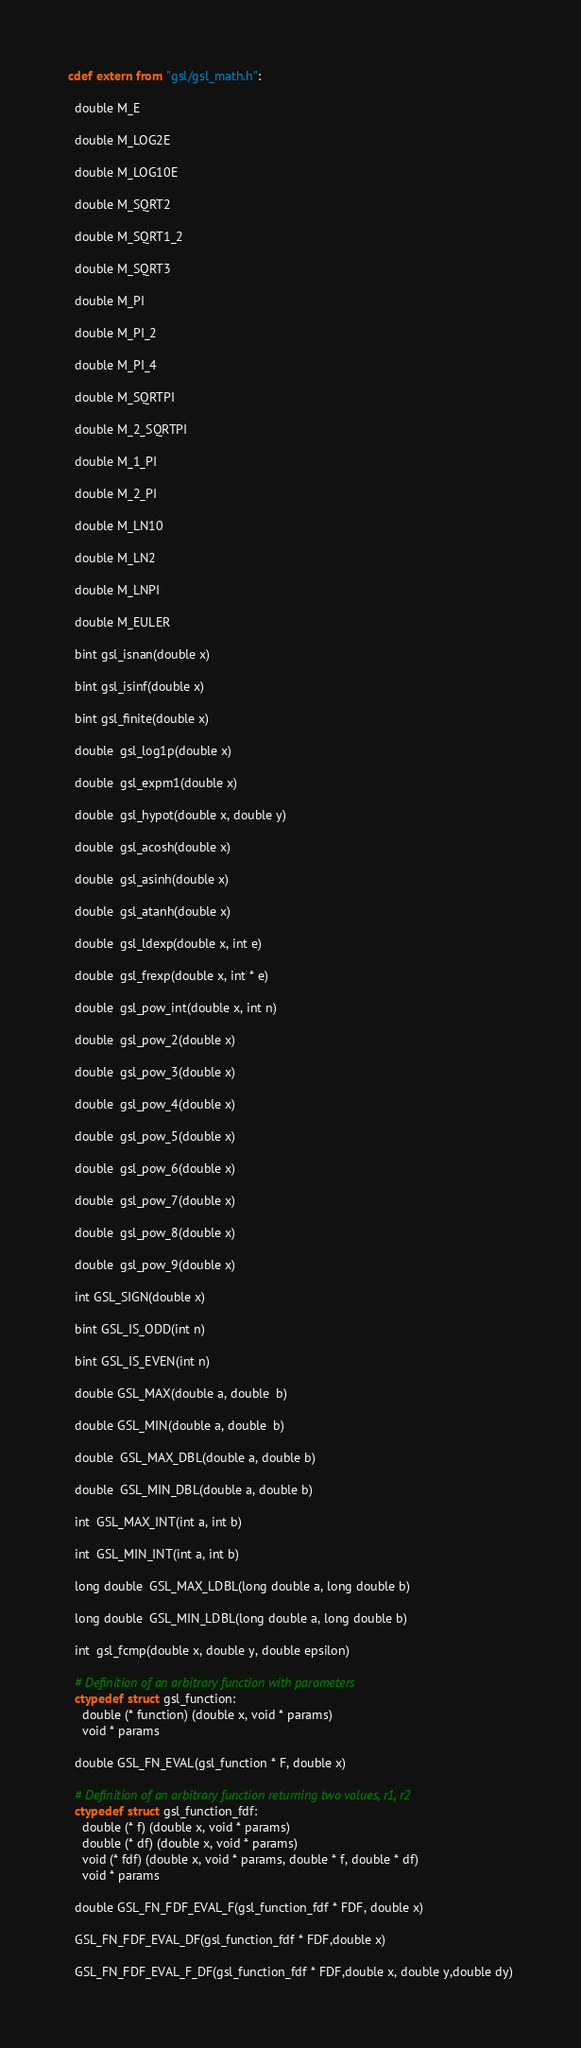Convert code to text. <code><loc_0><loc_0><loc_500><loc_500><_Cython_>cdef extern from "gsl/gsl_math.h":

  double M_E

  double M_LOG2E

  double M_LOG10E

  double M_SQRT2

  double M_SQRT1_2

  double M_SQRT3

  double M_PI

  double M_PI_2

  double M_PI_4

  double M_SQRTPI

  double M_2_SQRTPI

  double M_1_PI

  double M_2_PI

  double M_LN10

  double M_LN2

  double M_LNPI

  double M_EULER

  bint gsl_isnan(double x)

  bint gsl_isinf(double x)

  bint gsl_finite(double x)

  double  gsl_log1p(double x)

  double  gsl_expm1(double x)

  double  gsl_hypot(double x, double y)

  double  gsl_acosh(double x)

  double  gsl_asinh(double x)

  double  gsl_atanh(double x)

  double  gsl_ldexp(double x, int e)

  double  gsl_frexp(double x, int * e)

  double  gsl_pow_int(double x, int n)

  double  gsl_pow_2(double x)

  double  gsl_pow_3(double x)

  double  gsl_pow_4(double x)

  double  gsl_pow_5(double x)

  double  gsl_pow_6(double x)

  double  gsl_pow_7(double x)

  double  gsl_pow_8(double x)

  double  gsl_pow_9(double x)

  int GSL_SIGN(double x)

  bint GSL_IS_ODD(int n)

  bint GSL_IS_EVEN(int n)

  double GSL_MAX(double a, double  b)

  double GSL_MIN(double a, double  b)

  double  GSL_MAX_DBL(double a, double b)

  double  GSL_MIN_DBL(double a, double b)

  int  GSL_MAX_INT(int a, int b)

  int  GSL_MIN_INT(int a, int b)

  long double  GSL_MAX_LDBL(long double a, long double b)

  long double  GSL_MIN_LDBL(long double a, long double b)

  int  gsl_fcmp(double x, double y, double epsilon)

  # Definition of an arbitrary function with parameters
  ctypedef struct gsl_function:
    double (* function) (double x, void * params)
    void * params

  double GSL_FN_EVAL(gsl_function * F, double x)

  # Definition of an arbitrary function returning two values, r1, r2
  ctypedef struct gsl_function_fdf:
    double (* f) (double x, void * params)
    double (* df) (double x, void * params)
    void (* fdf) (double x, void * params, double * f, double * df)
    void * params

  double GSL_FN_FDF_EVAL_F(gsl_function_fdf * FDF, double x)

  GSL_FN_FDF_EVAL_DF(gsl_function_fdf * FDF,double x)

  GSL_FN_FDF_EVAL_F_DF(gsl_function_fdf * FDF,double x, double y,double dy)

</code> 